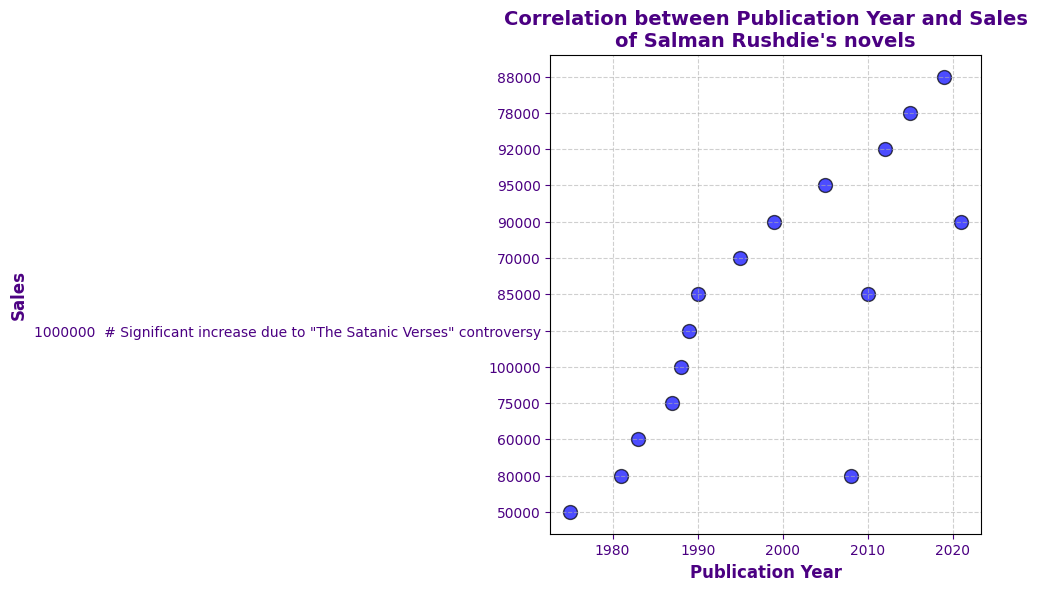What event is highlighted by the red annotation in the figure? The red annotation in the figure highlights the "The Satanic Verses Controversy" and its corresponding significant sales increase in 1989. The annotation points to the specific year and sales spike.
Answer: "The Satanic Verses" controversy in 1989 How did the sales in 1989 compare to the sales in the years immediately before and after it? In 1989, the sales spiked to 1,000,000 compared to 100,000 in 1988 and 85,000 in 1990, indicating a major increase during the controversy and a subsequent decline.
Answer: Sales surged in 1989 What is the trend in sales from 1975 to 2021? The general trend in sales shows various fluctuations with a significant peak in 1989, but overall, the sales appear to stabilize in the range of 75,000 to 95,000 in more recent years.
Answer: Fluctuating with a peak in 1989 Which year saw the highest sales of Salman Rushdie's novels? The year 1989 saw the highest sales, reaching 1,000,000, which is marked by a red annotation indicating an extraordinary event.
Answer: 1989 Approximately what were the average sales of Salman Rushdie's novels from 1975 to 1988, excluding the 1989 spike? To find the average, sum the sales from 1975 to 1988 (50000 + 80000 + 60000 + 75000 + 100000) and divide by the number of years (5): (375000) / 5 = 75,000.
Answer: 75,000 Compare the sales in 1995 to those in 2021. Are they higher, lower, or about the same? Sales in 1995 were 70,000, whereas in 2021, they were 90,000. Thus, the sales in 2021 are higher compared to 1995.
Answer: Higher in 2021 Did the sales return to pre-1989 levels in the years following the controversy? After 1989, sales dropped, and although they increased slightly in subsequent years, they generally returned to levels around 75,000 - 95,000 seen before the spike, indicating they did return to pre-1989 levels.
Answer: Yes, they returned Is there a noticeable trend in sales between 2000 and 2021? Between 2000 and 2021, the sales seem to stabilize, with figures fluctuating between 80,000 and 95,000, which indicates a steady trend in the recent years.
Answer: Stable trend What is the lowest sales figure recorded in the provided data, and in which year did it occur? The lowest sales figure recorded is 50,000 in the year 1975.
Answer: 50,000 in 1975 